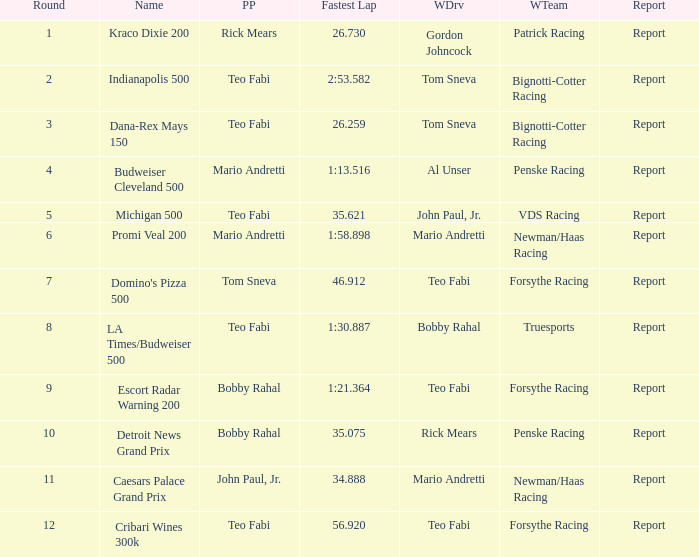Which Rd took place at the Indianapolis 500? 2.0. 